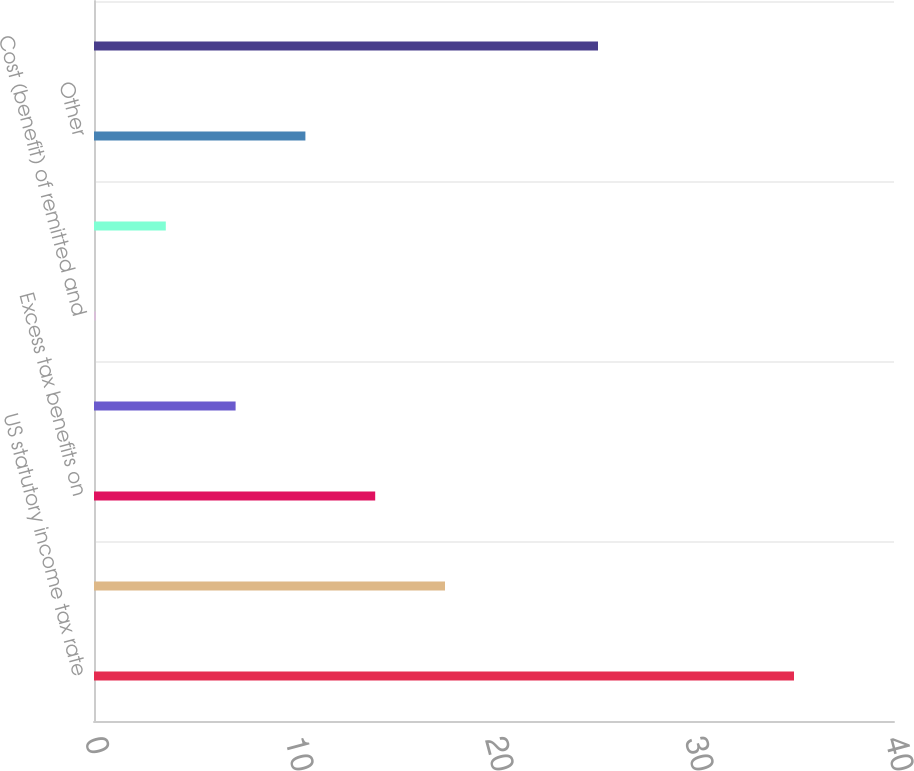Convert chart. <chart><loc_0><loc_0><loc_500><loc_500><bar_chart><fcel>US statutory income tax rate<fcel>Foreign rates varying from US<fcel>Excess tax benefits on<fcel>State income taxes net of<fcel>Cost (benefit) of remitted and<fcel>Net change in valuation<fcel>Other<fcel>Effective income tax rate<nl><fcel>35<fcel>17.55<fcel>14.06<fcel>7.08<fcel>0.1<fcel>3.59<fcel>10.57<fcel>25.2<nl></chart> 